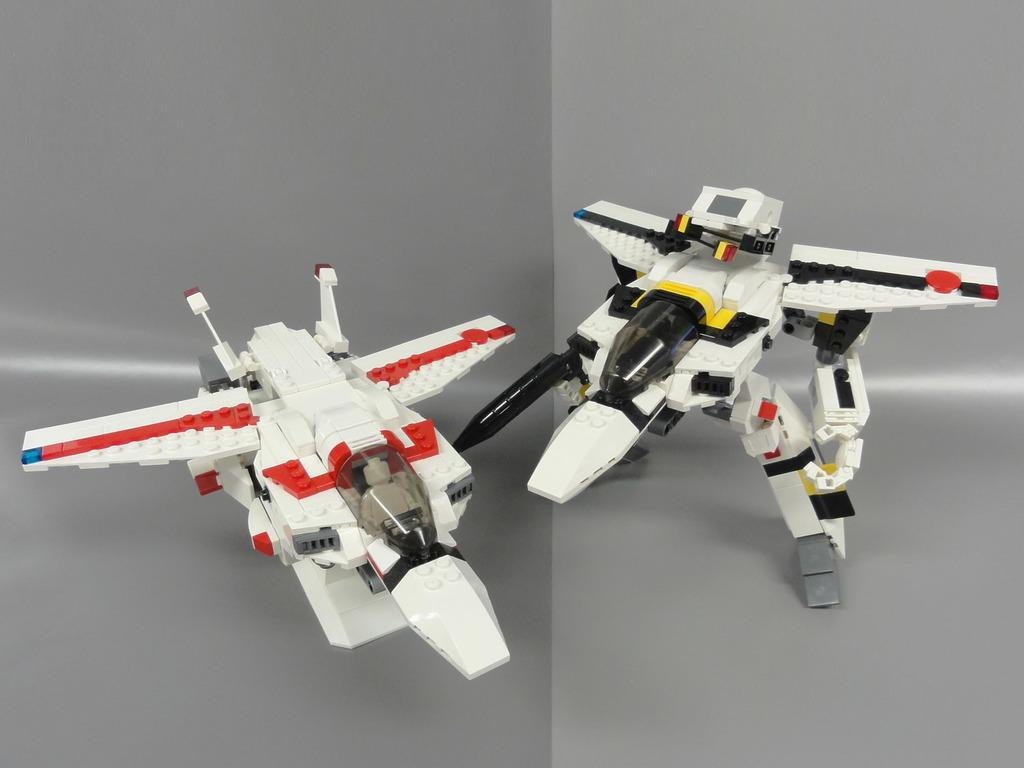How many toys can be seen in the image? There are two toys in the image. What is the background of the image? The background of the image features a plane. What type of dress is the dinosaur wearing in the image? There are no dinosaurs or dresses present in the image. 